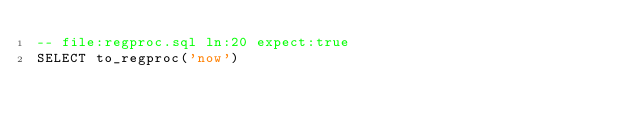<code> <loc_0><loc_0><loc_500><loc_500><_SQL_>-- file:regproc.sql ln:20 expect:true
SELECT to_regproc('now')
</code> 